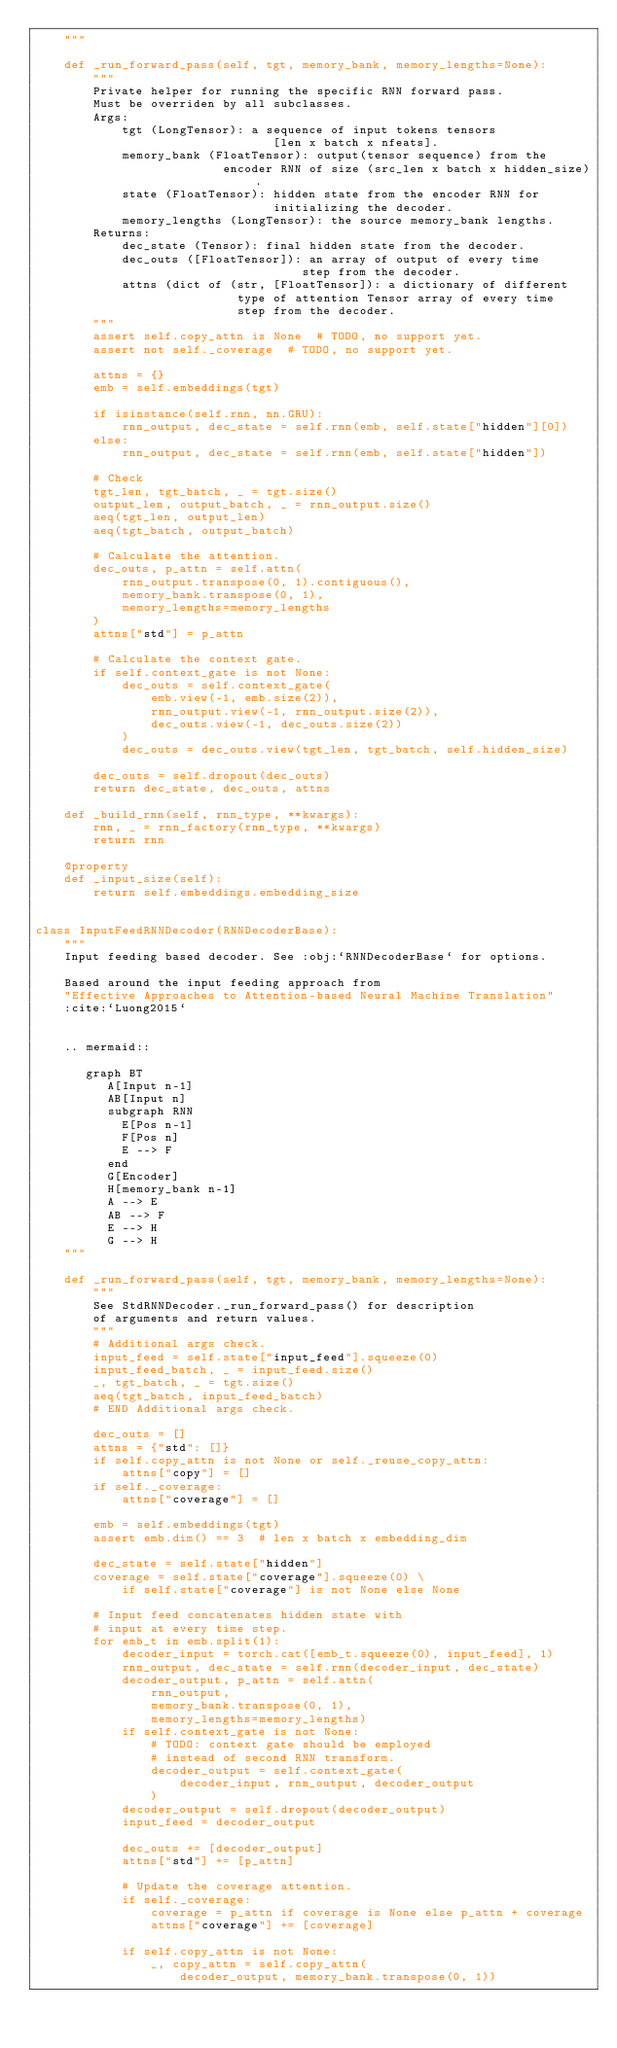Convert code to text. <code><loc_0><loc_0><loc_500><loc_500><_Python_>    """

    def _run_forward_pass(self, tgt, memory_bank, memory_lengths=None):
        """
        Private helper for running the specific RNN forward pass.
        Must be overriden by all subclasses.
        Args:
            tgt (LongTensor): a sequence of input tokens tensors
                                 [len x batch x nfeats].
            memory_bank (FloatTensor): output(tensor sequence) from the
                          encoder RNN of size (src_len x batch x hidden_size).
            state (FloatTensor): hidden state from the encoder RNN for
                                 initializing the decoder.
            memory_lengths (LongTensor): the source memory_bank lengths.
        Returns:
            dec_state (Tensor): final hidden state from the decoder.
            dec_outs ([FloatTensor]): an array of output of every time
                                     step from the decoder.
            attns (dict of (str, [FloatTensor]): a dictionary of different
                            type of attention Tensor array of every time
                            step from the decoder.
        """
        assert self.copy_attn is None  # TODO, no support yet.
        assert not self._coverage  # TODO, no support yet.

        attns = {}
        emb = self.embeddings(tgt)

        if isinstance(self.rnn, nn.GRU):
            rnn_output, dec_state = self.rnn(emb, self.state["hidden"][0])
        else:
            rnn_output, dec_state = self.rnn(emb, self.state["hidden"])

        # Check
        tgt_len, tgt_batch, _ = tgt.size()
        output_len, output_batch, _ = rnn_output.size()
        aeq(tgt_len, output_len)
        aeq(tgt_batch, output_batch)

        # Calculate the attention.
        dec_outs, p_attn = self.attn(
            rnn_output.transpose(0, 1).contiguous(),
            memory_bank.transpose(0, 1),
            memory_lengths=memory_lengths
        )
        attns["std"] = p_attn

        # Calculate the context gate.
        if self.context_gate is not None:
            dec_outs = self.context_gate(
                emb.view(-1, emb.size(2)),
                rnn_output.view(-1, rnn_output.size(2)),
                dec_outs.view(-1, dec_outs.size(2))
            )
            dec_outs = dec_outs.view(tgt_len, tgt_batch, self.hidden_size)

        dec_outs = self.dropout(dec_outs)
        return dec_state, dec_outs, attns

    def _build_rnn(self, rnn_type, **kwargs):
        rnn, _ = rnn_factory(rnn_type, **kwargs)
        return rnn

    @property
    def _input_size(self):
        return self.embeddings.embedding_size


class InputFeedRNNDecoder(RNNDecoderBase):
    """
    Input feeding based decoder. See :obj:`RNNDecoderBase` for options.

    Based around the input feeding approach from
    "Effective Approaches to Attention-based Neural Machine Translation"
    :cite:`Luong2015`


    .. mermaid::

       graph BT
          A[Input n-1]
          AB[Input n]
          subgraph RNN
            E[Pos n-1]
            F[Pos n]
            E --> F
          end
          G[Encoder]
          H[memory_bank n-1]
          A --> E
          AB --> F
          E --> H
          G --> H
    """

    def _run_forward_pass(self, tgt, memory_bank, memory_lengths=None):
        """
        See StdRNNDecoder._run_forward_pass() for description
        of arguments and return values.
        """
        # Additional args check.
        input_feed = self.state["input_feed"].squeeze(0)
        input_feed_batch, _ = input_feed.size()
        _, tgt_batch, _ = tgt.size()
        aeq(tgt_batch, input_feed_batch)
        # END Additional args check.

        dec_outs = []
        attns = {"std": []}
        if self.copy_attn is not None or self._reuse_copy_attn:
            attns["copy"] = []
        if self._coverage:
            attns["coverage"] = []

        emb = self.embeddings(tgt)
        assert emb.dim() == 3  # len x batch x embedding_dim

        dec_state = self.state["hidden"]
        coverage = self.state["coverage"].squeeze(0) \
            if self.state["coverage"] is not None else None

        # Input feed concatenates hidden state with
        # input at every time step.
        for emb_t in emb.split(1):
            decoder_input = torch.cat([emb_t.squeeze(0), input_feed], 1)
            rnn_output, dec_state = self.rnn(decoder_input, dec_state)
            decoder_output, p_attn = self.attn(
                rnn_output,
                memory_bank.transpose(0, 1),
                memory_lengths=memory_lengths)
            if self.context_gate is not None:
                # TODO: context gate should be employed
                # instead of second RNN transform.
                decoder_output = self.context_gate(
                    decoder_input, rnn_output, decoder_output
                )
            decoder_output = self.dropout(decoder_output)
            input_feed = decoder_output

            dec_outs += [decoder_output]
            attns["std"] += [p_attn]

            # Update the coverage attention.
            if self._coverage:
                coverage = p_attn if coverage is None else p_attn + coverage
                attns["coverage"] += [coverage]

            if self.copy_attn is not None:
                _, copy_attn = self.copy_attn(
                    decoder_output, memory_bank.transpose(0, 1))</code> 